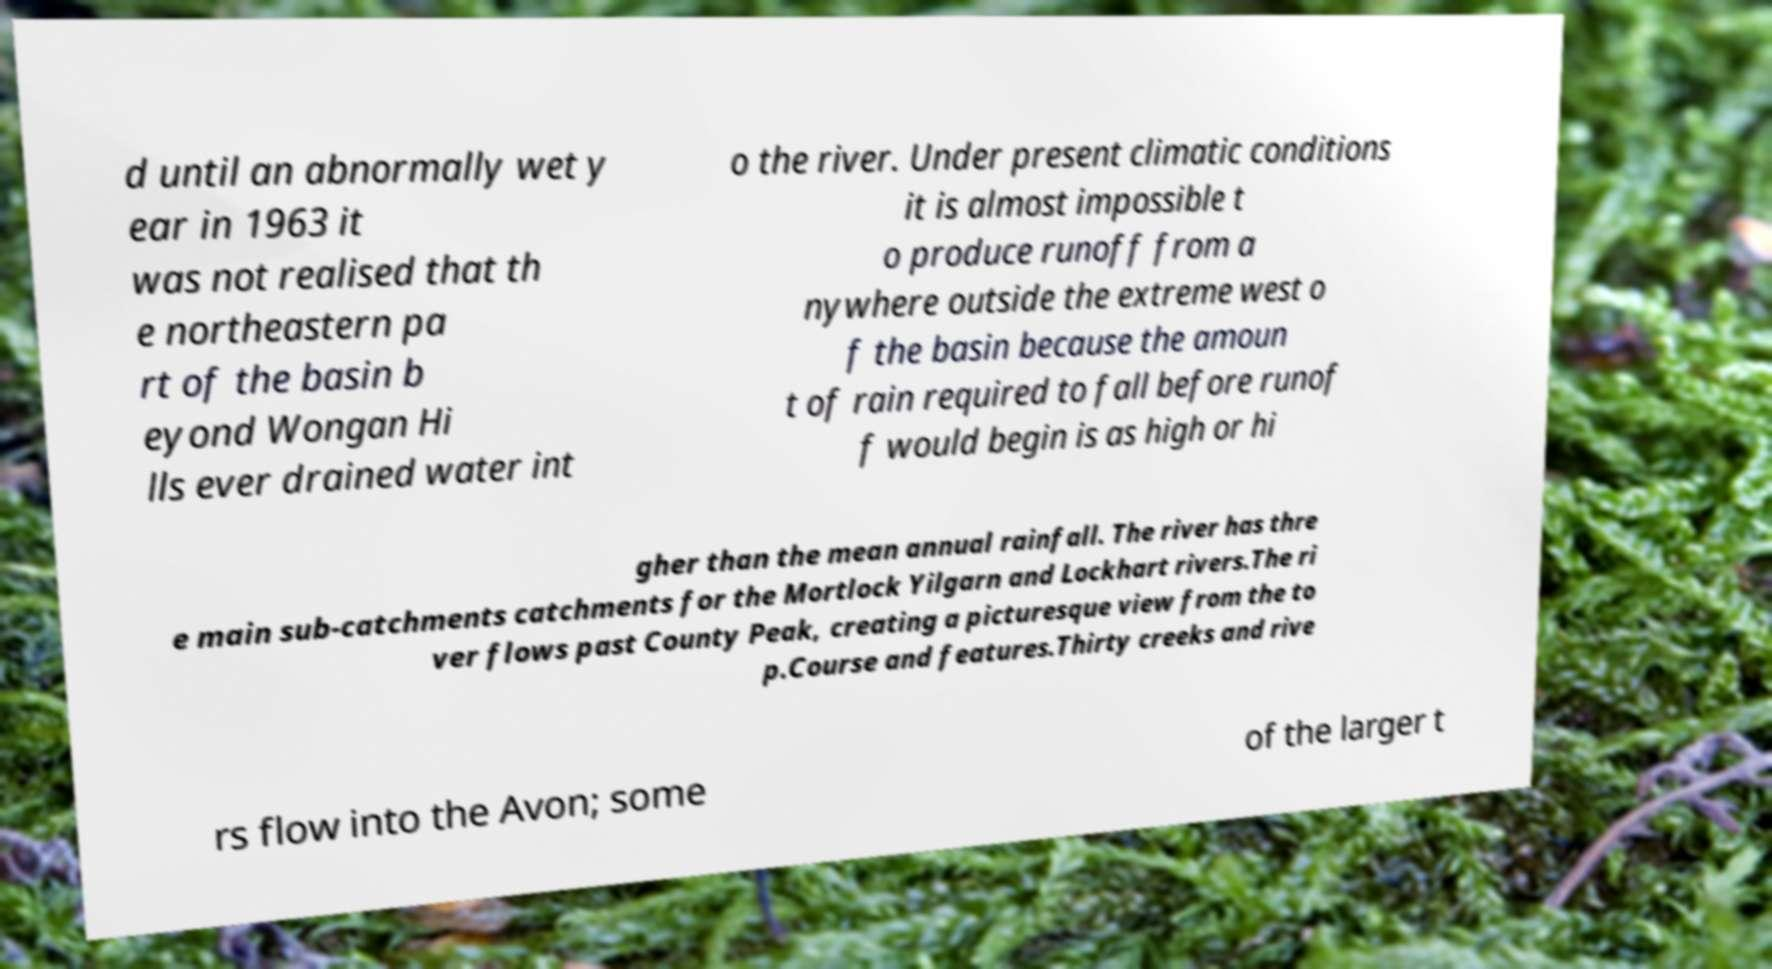Can you read and provide the text displayed in the image?This photo seems to have some interesting text. Can you extract and type it out for me? d until an abnormally wet y ear in 1963 it was not realised that th e northeastern pa rt of the basin b eyond Wongan Hi lls ever drained water int o the river. Under present climatic conditions it is almost impossible t o produce runoff from a nywhere outside the extreme west o f the basin because the amoun t of rain required to fall before runof f would begin is as high or hi gher than the mean annual rainfall. The river has thre e main sub-catchments catchments for the Mortlock Yilgarn and Lockhart rivers.The ri ver flows past County Peak, creating a picturesque view from the to p.Course and features.Thirty creeks and rive rs flow into the Avon; some of the larger t 